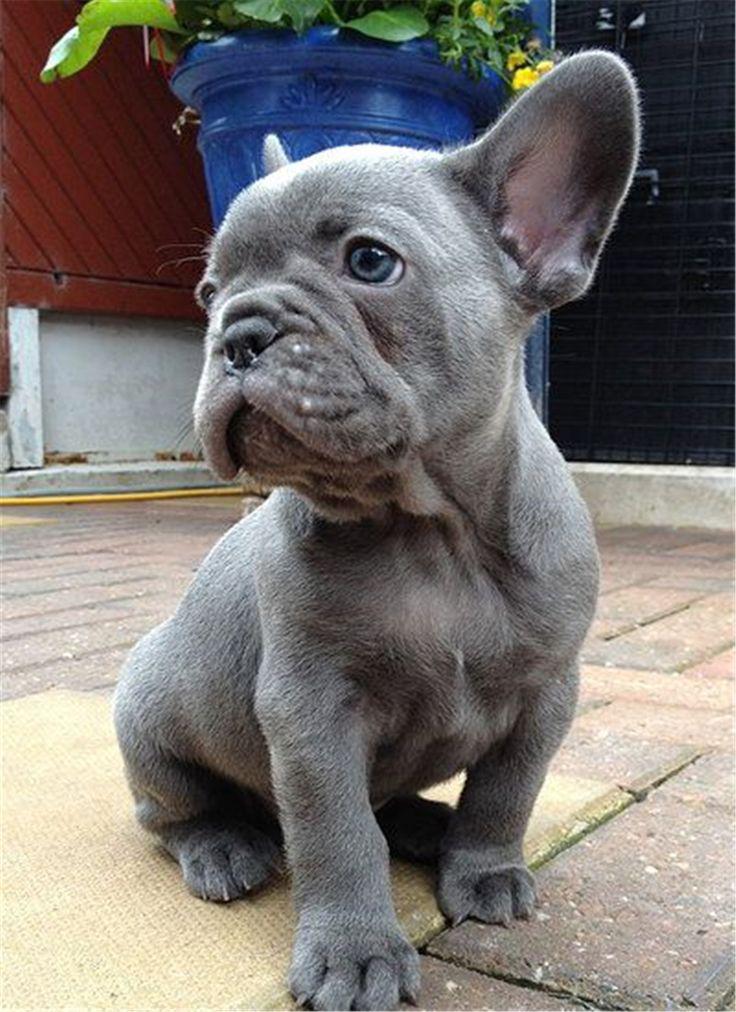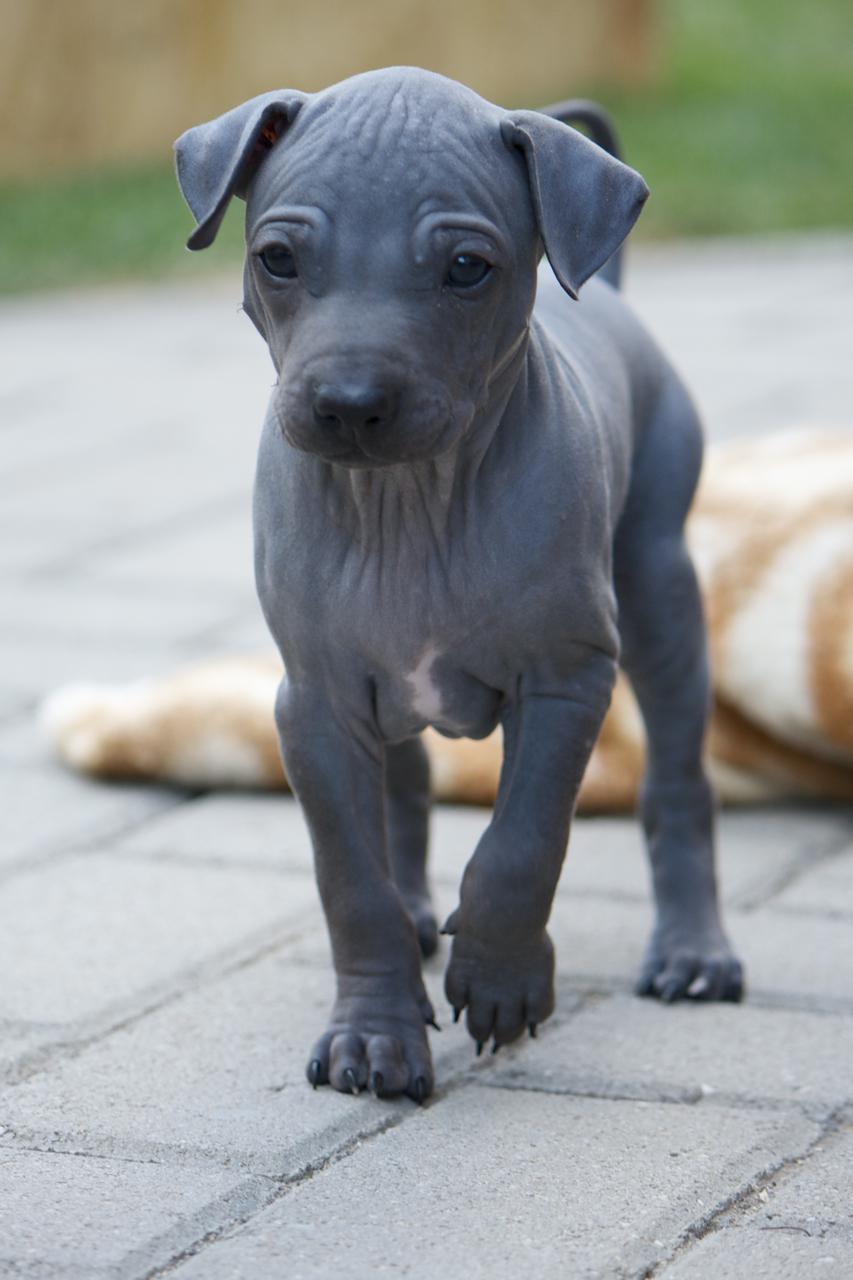The first image is the image on the left, the second image is the image on the right. Considering the images on both sides, is "The left image shows a grey bulldog in front of a gray background, and the right image shows a grey bulldog sitting in front of something bright orange." valid? Answer yes or no. No. The first image is the image on the left, the second image is the image on the right. Examine the images to the left and right. Is the description "The dog in the image on the right is standing up on all four feet." accurate? Answer yes or no. Yes. 